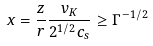Convert formula to latex. <formula><loc_0><loc_0><loc_500><loc_500>x = \frac { z } { r } \frac { v _ { K } } { 2 ^ { 1 / 2 } c _ { s } } \geq \Gamma ^ { - 1 / 2 }</formula> 